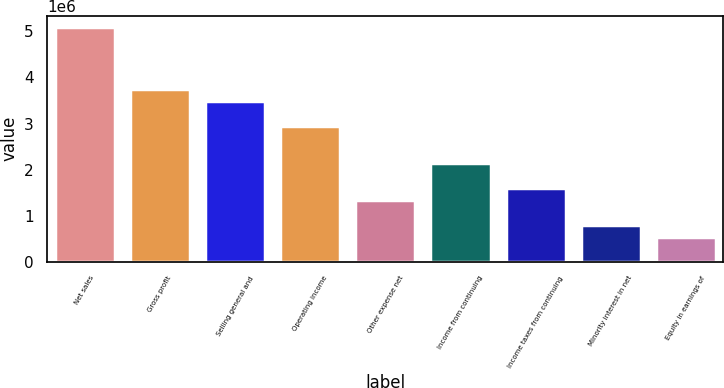<chart> <loc_0><loc_0><loc_500><loc_500><bar_chart><fcel>Net sales<fcel>Gross profit<fcel>Selling general and<fcel>Operating income<fcel>Other expense net<fcel>Income from continuing<fcel>Income taxes from continuing<fcel>Minority interest in net<fcel>Equity in earnings of<nl><fcel>5.08372e+06<fcel>3.7459e+06<fcel>3.47834e+06<fcel>2.94321e+06<fcel>1.33782e+06<fcel>2.14052e+06<fcel>1.60539e+06<fcel>802694<fcel>535130<nl></chart> 